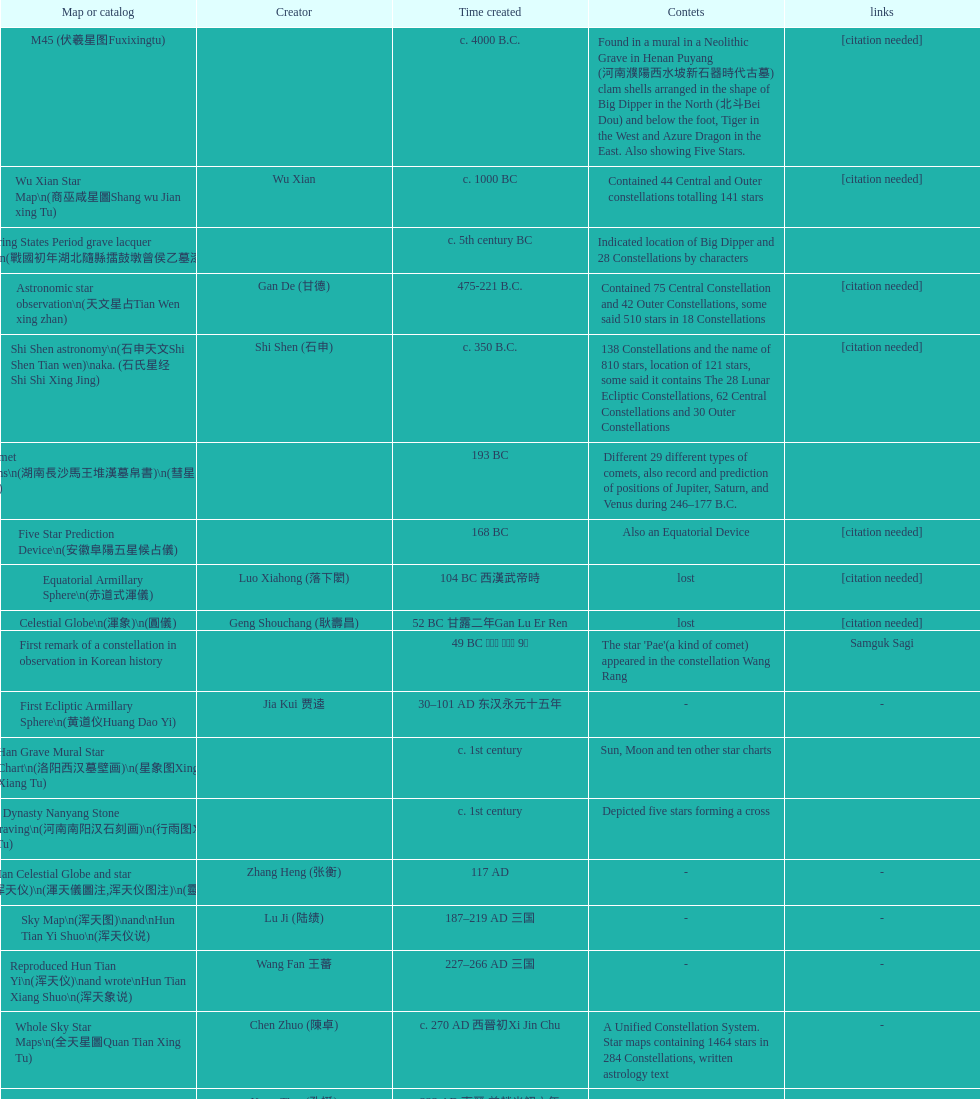What is the name of the oldest map/catalog? M45. 